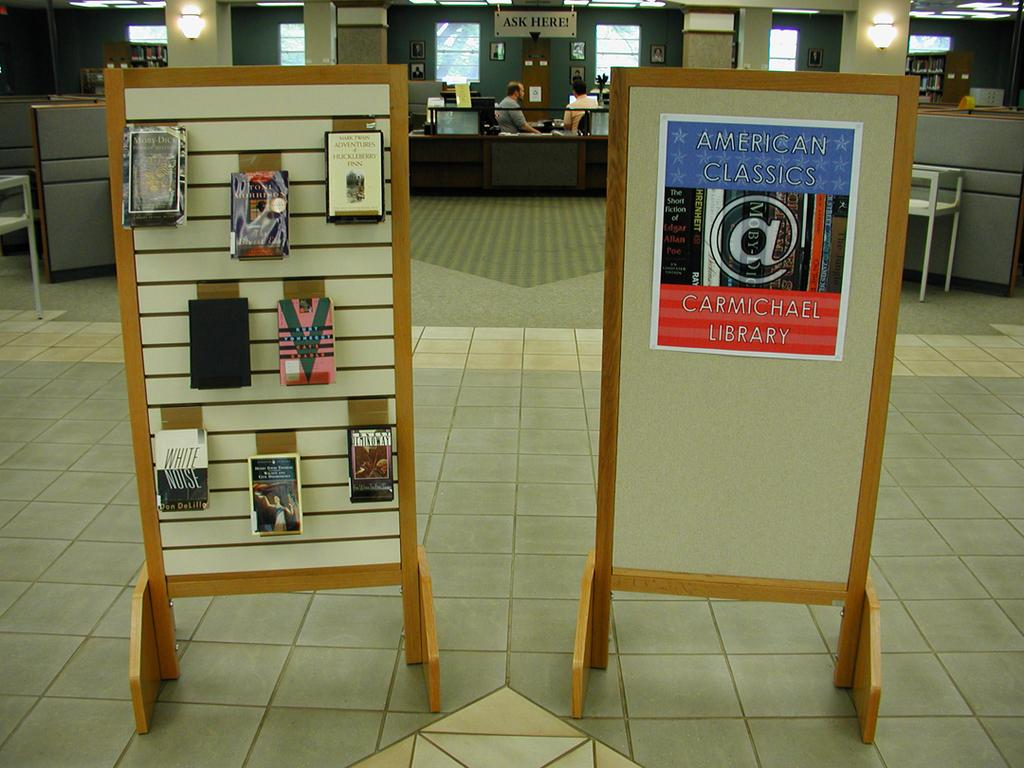<image>
Relay a brief, clear account of the picture shown. To stands are at the entrance of a library, one bearing several books, the other a poster advertising classical American books at the Carmichael Library 